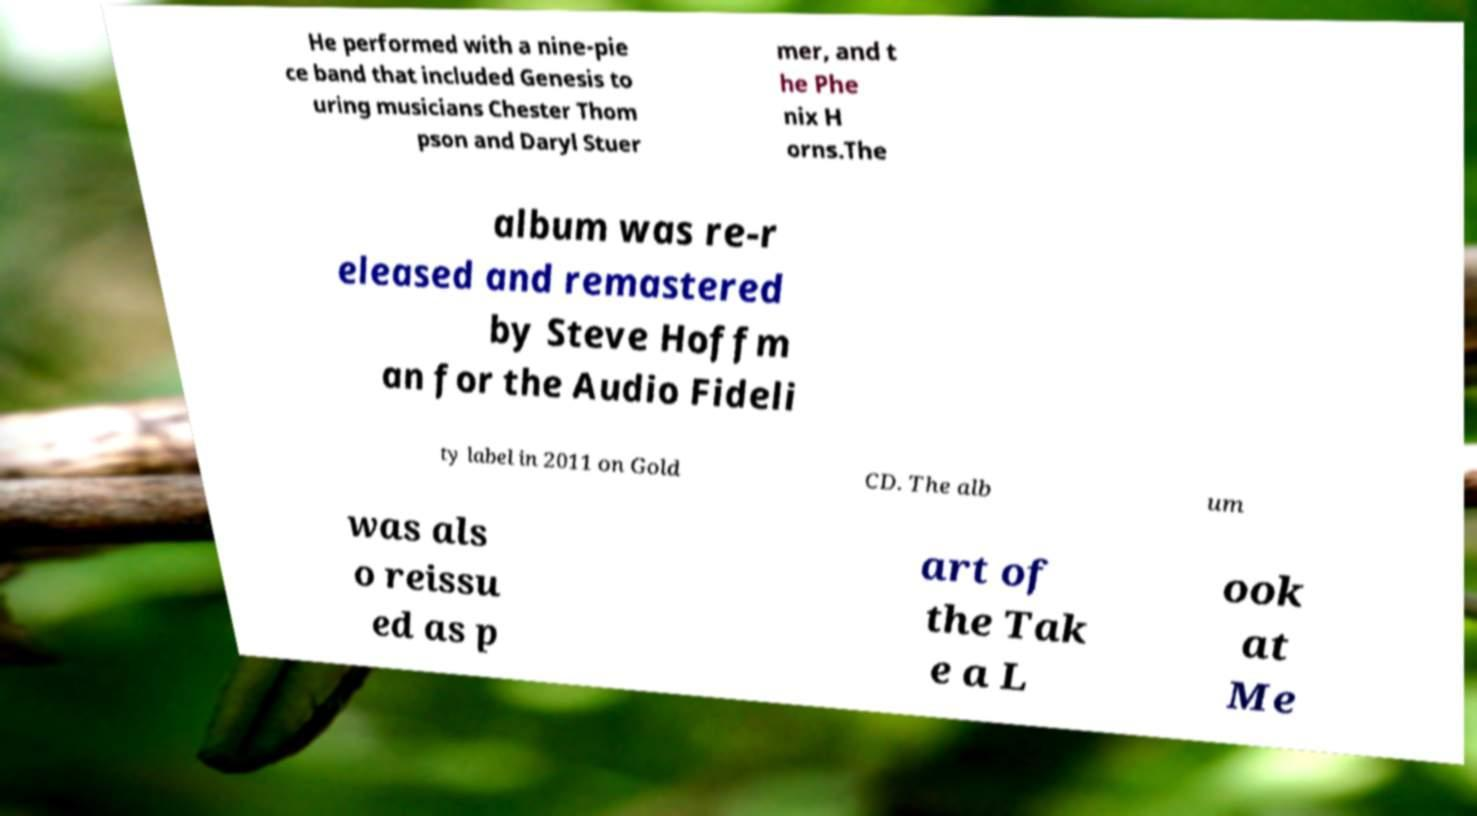Can you read and provide the text displayed in the image?This photo seems to have some interesting text. Can you extract and type it out for me? He performed with a nine-pie ce band that included Genesis to uring musicians Chester Thom pson and Daryl Stuer mer, and t he Phe nix H orns.The album was re-r eleased and remastered by Steve Hoffm an for the Audio Fideli ty label in 2011 on Gold CD. The alb um was als o reissu ed as p art of the Tak e a L ook at Me 